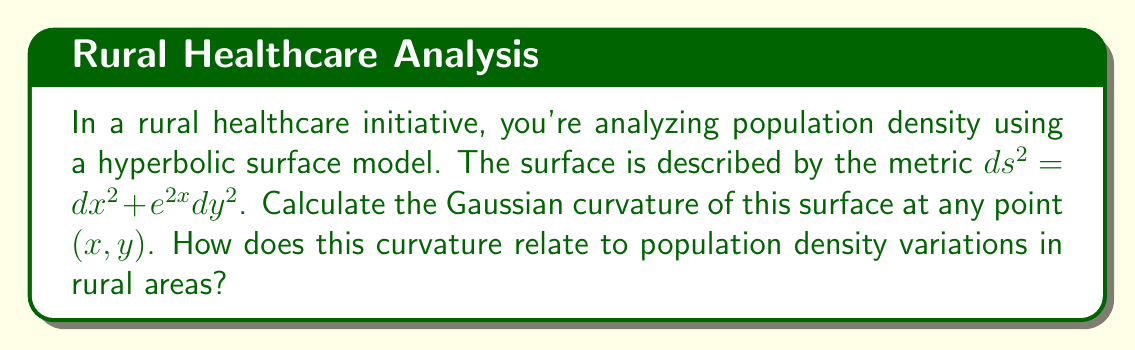What is the answer to this math problem? To calculate the Gaussian curvature of the hyperbolic surface, we'll follow these steps:

1) The metric is given as $ds^2 = dx^2 + e^{2x}dy^2$. We can identify the metric coefficients:
   $E = 1$, $F = 0$, $G = e^{2x}$

2) For a surface with metric $ds^2 = E dx^2 + 2F dx dy + G dy^2$, the Gaussian curvature K is given by:

   $$K = -\frac{1}{\sqrt{EG-F^2}}\left(\frac{\partial}{\partial x}\left(\frac{G_x}{\sqrt{EG-F^2}}\right) + \frac{\partial}{\partial y}\left(\frac{E_y}{\sqrt{EG-F^2}}\right)\right)$$

   where subscripts denote partial derivatives.

3) Calculate the necessary derivatives:
   $E_x = 0$, $E_y = 0$, $G_x = 2e^{2x}$, $G_y = 0$

4) Simplify $\sqrt{EG-F^2} = \sqrt{1 \cdot e^{2x} - 0^2} = e^x$

5) Substitute into the curvature formula:

   $$K = -\frac{1}{e^x}\left(\frac{\partial}{\partial x}\left(\frac{2e^{2x}}{e^x}\right) + \frac{\partial}{\partial y}(0)\right)$$

6) Simplify:
   $$K = -\frac{1}{e^x}\frac{\partial}{\partial x}(2e^x) = -\frac{1}{e^x} \cdot 2e^x = -2$$

7) Therefore, the Gaussian curvature is constant and equal to -2 at all points on the surface.

In the context of rural healthcare, this constant negative curvature implies that the population density decreases exponentially as we move away from central areas (represented by increasing x). This models the typical scenario in rural areas where population becomes sparser farther from town centers, highlighting the challenges in providing widespread healthcare coverage.
Answer: $K = -2$ 